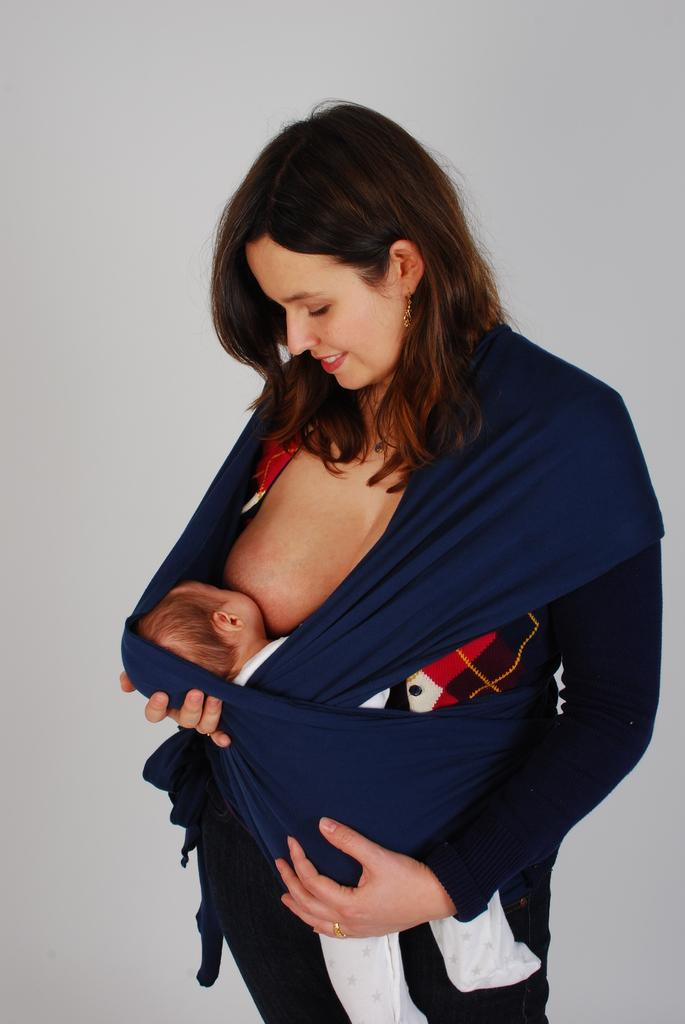Who is the main subject in the image? There is a woman in the image. What is the woman doing in the image? The woman is feeding her child. What can be seen behind the woman in the image? There is a wall behind the woman. What type of tiger can be seen in the image? There is no tiger present in the image. Is the woman in the image a lawyer? The image does not provide any information about the woman's profession, so we cannot determine if she is a lawyer. 